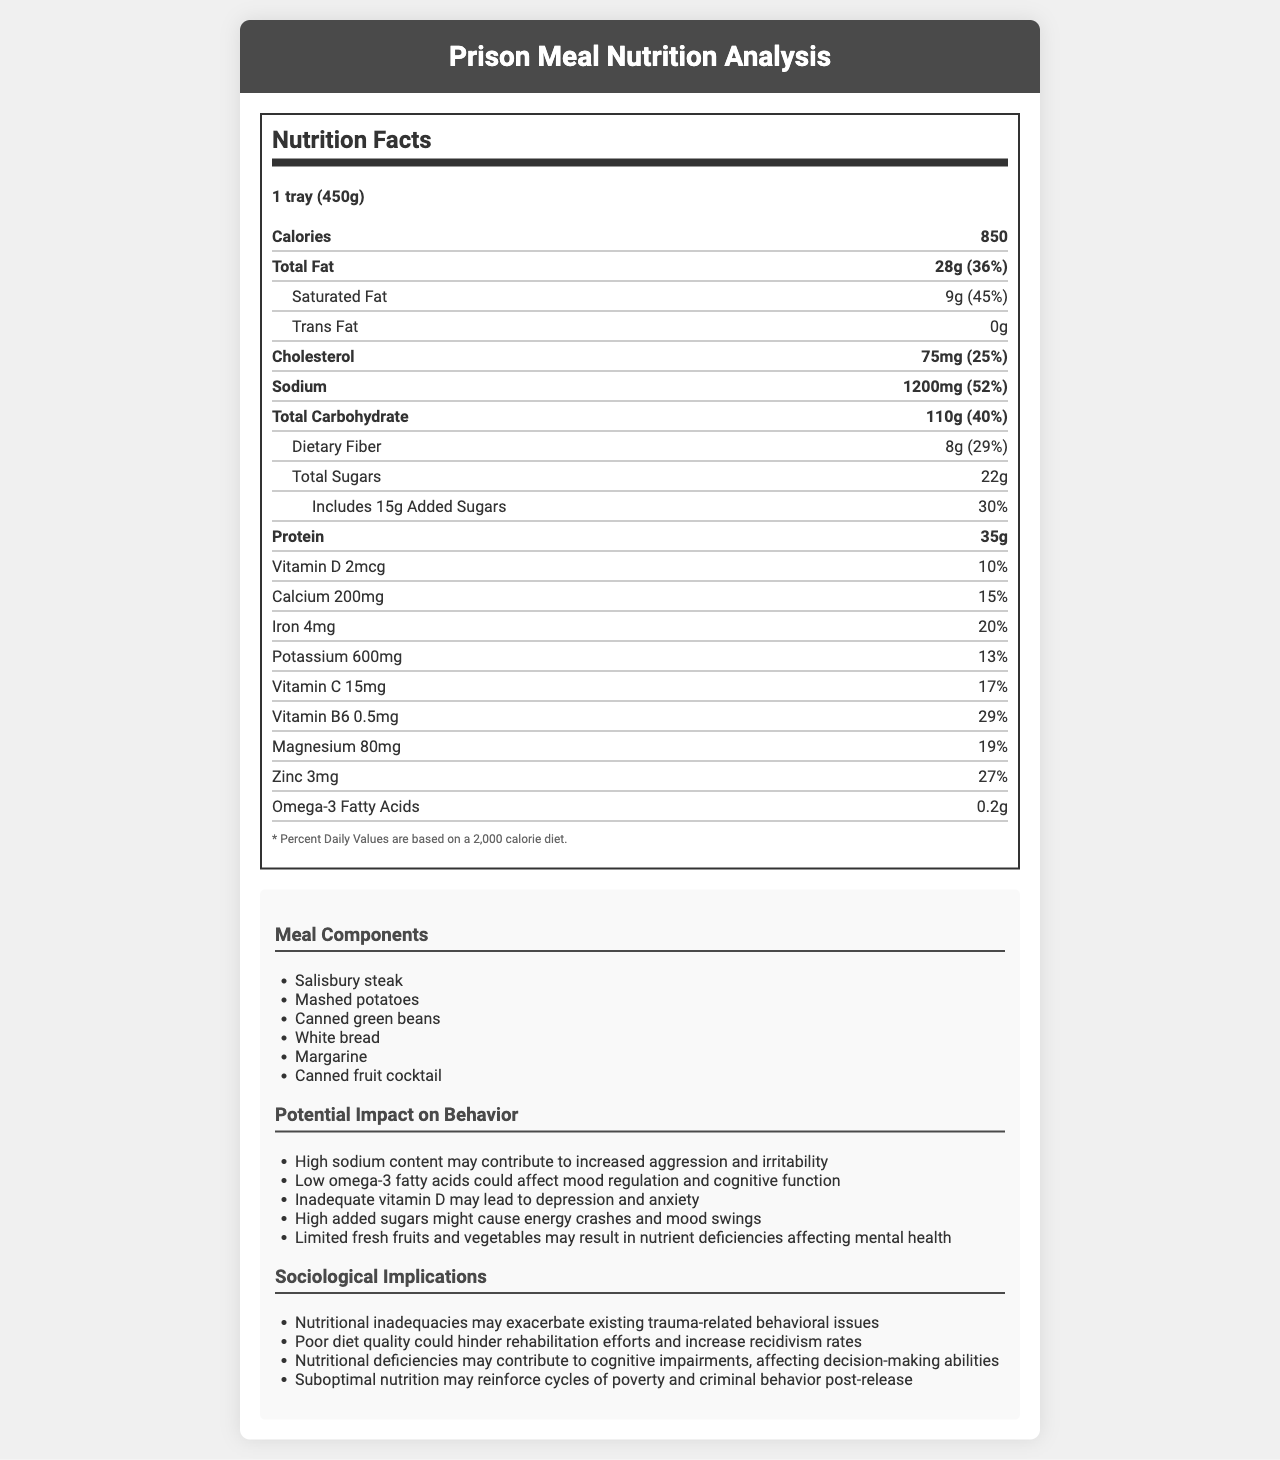how many servings are in one container? The text states that there is "1 tray (450g)" and "servings per container: 1."
Answer: 1 how much saturated fat does the meal contain? The document lists "Saturated Fat: 9g (45% DV)."
Answer: 9g what is the daily value percentage of sodium in the meal? The document mentions "Sodium: 1200mg (52% DV)."
Answer: 52% how many grams of added sugars are in the meal? It is indicated under the indent section for sugars: "Includes 15g Added Sugars (30% DV)."
Answer: 15g what are the primary meal components? The additional info section lists these items under "Meal Components."
Answer: Salisbury steak, Mashed potatoes, Canned green beans, White bread, Margarine, Canned fruit cocktail which nutrient has the highest daily value percentage? 
A. Saturated Fat 
B. Sodium 
C. Dietary Fiber 
D. Protein The nutrient with the highest daily value percentage listed is Sodium at 52%.
Answer: B. Sodium which potential behavioral issue is NOT mentioned as being impacted by the meal? 
i. Increased aggression 
ii. Mood swings 
iii. Cognitive function improvement 
iv. Depression All mentioned issues are negative impacts, and cognitive function improvement is not listed under "Potential Impact on Behavior."
Answer: iii. Cognitive function improvement is the amount of trans fat in the meal zero? Trans fat is listed as "0g" in the document.
Answer: Yes summarize the main idea of the document. A detailed nutrition label breaks down the content per serving, accompanied by potential behavioral impacts due to nutritional deficiencies and broader sociological implications related to inmate rehabilitation and post-release outcomes.
Answer: The document analyzes the nutritional content of a standard prison meal, listing components and nutrient values, and discusses the potential impact of the meal's nutritional inadequacies on inmate behavior and sociological implications. what is the exact amount of vitamin B12 in the meal? The document does not list any information about vitamin B12 content.
Answer: Not enough information how many calories does the prison meal provide? The document clearly states, "Calories: 850."
Answer: 850 what is the protein content as a percentage of the daily value? Under Protein in the document, it is listed as "35g (70% DV)."
Answer: 70% are fresh fruits and vegetables a significant part of the meal? The document states "Limited fresh fruits and vegetables" under potential impacts, indicating they are not a significant part.
Answer: No how much cholesterol is in the meal? The document lists cholesterol as "75mg (25% DV)."
Answer: 75mg which of the following nutrients has the lowest daily value percentage? 
A. Calcium 
B. Potassium 
C. Zinc 
D. Iron The daily value percentages are Calcium (15%), Potassium (13%), Zinc (27%), and Iron (20%). Potassium has the lowest daily value percentage at 13%.
Answer: B. Potassium 